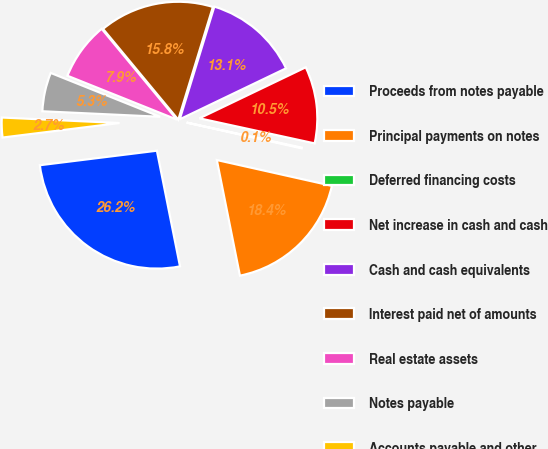<chart> <loc_0><loc_0><loc_500><loc_500><pie_chart><fcel>Proceeds from notes payable<fcel>Principal payments on notes<fcel>Deferred financing costs<fcel>Net increase in cash and cash<fcel>Cash and cash equivalents<fcel>Interest paid net of amounts<fcel>Real estate assets<fcel>Notes payable<fcel>Accounts payable and other<nl><fcel>26.17%<fcel>18.35%<fcel>0.1%<fcel>10.53%<fcel>13.14%<fcel>15.75%<fcel>7.92%<fcel>5.32%<fcel>2.71%<nl></chart> 